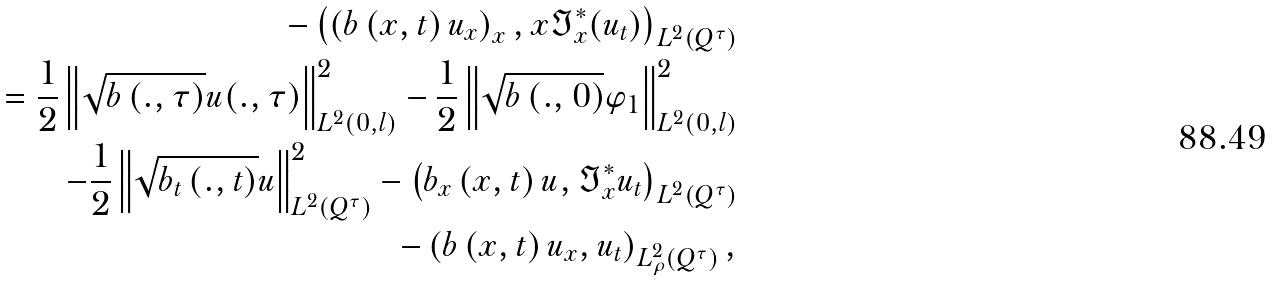<formula> <loc_0><loc_0><loc_500><loc_500>- \left ( \left ( b \left ( x , t \right ) u _ { x } \right ) _ { x } , x \Im _ { x } ^ { * } ( u _ { t } ) \right ) _ { L ^ { 2 } ( Q ^ { \tau } ) } \\ = \frac { 1 } { 2 } \left \| \sqrt { b \left ( . , \tau \right ) } u ( . , \tau ) \right \| _ { L ^ { 2 } ( 0 , l ) } ^ { 2 } - \frac { 1 } { 2 } \left \| \sqrt { b \left ( . , 0 \right ) } \varphi _ { 1 } \right \| _ { L ^ { 2 } ( 0 , l ) } ^ { 2 } \\ - \frac { 1 } { 2 } \left \| \sqrt { b _ { t } \left ( . , t \right ) } u \right \| _ { L ^ { 2 } ( Q ^ { \tau } ) } ^ { 2 } - \left ( b _ { x } \left ( x , t \right ) u , \Im _ { x } ^ { * } u _ { t } \right ) _ { L ^ { 2 } ( Q ^ { \tau } ) } \\ - \left ( b \left ( x , t \right ) u _ { x } , u _ { t } \right ) _ { L _ { \rho } ^ { 2 } ( Q ^ { \tau } ) } ,</formula> 